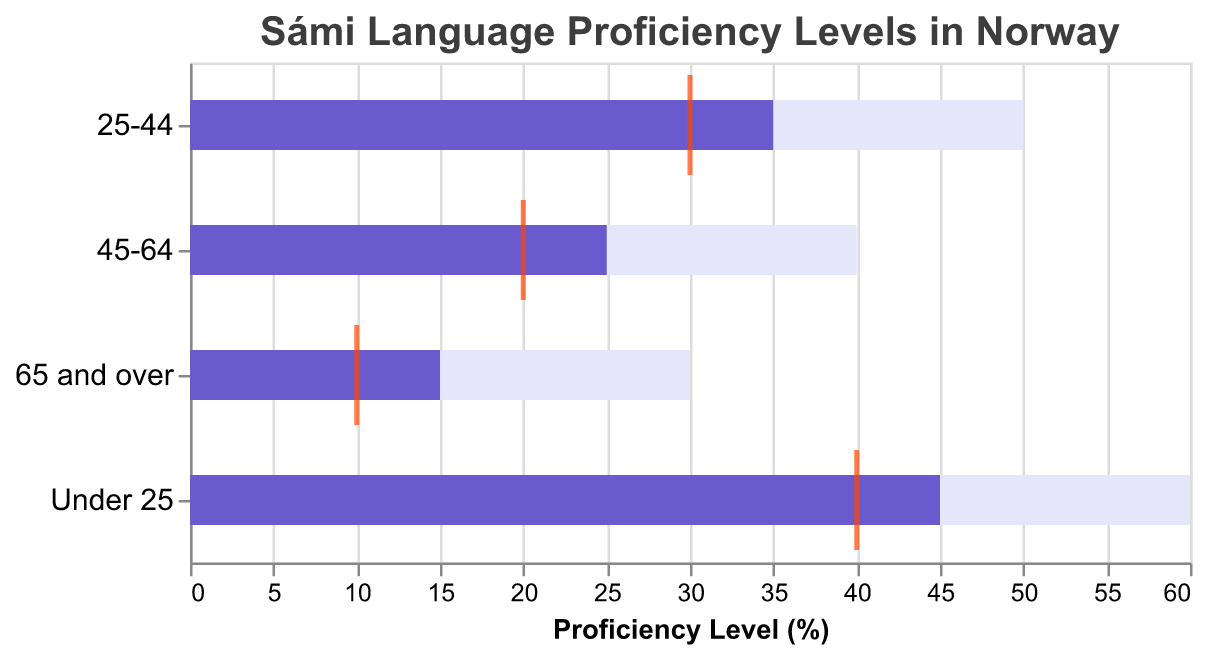How many age groups are displayed in the figure? The figure shows data for different age groups represented on the vertical axis. By counting the distinct labels, we can see there are four age groups: "Under 25", "25-44", "45-64", and "65 and over".
Answer: Four What is the proficiency level target for the "Under 25" age group? The target proficiency level for each age group is represented by the length of the light purple bars. According to the data, the target for the "Under 25" age group is 60%.
Answer: 60% Which age group has the highest average proficiency level in Sámi language? The average proficiency level for each age group is indicated by the position of the orange tick mark. By examining the figure, the "Under 25" age group has the highest average level at 40%.
Answer: Under 25 What is the difference between the target and proficient levels for the "25-44" age group? The target level for the "25-44" age group is 50%, and the proficient level is 35%. Subtracting these gives us 50 - 35 = 15.
Answer: 15 Which age group shows the smallest gap between the proficient and average proficiency levels? The proficient and average proficiency levels can be compared for each age group. The smallest gap is for the "25-44" age group, where the proficiency level is 35% and the average is 30%, resulting in a gap of 5.
Answer: 25-44 In which age group is the actual (proficient) level closest to the target level? By comparing the lengths of the light purple (target) and dark purple (proficient) bars for each age group, we observe that the smallest disparity between target and proficient levels is in the "25-44" age group (35 proficient versus 50 target, a difference of 15).
Answer: 25-44 What is the total proficiency level sum across all age groups? To find the total sum, we add the proficiency levels for all age groups: 45 (Under 25) + 35 (25-44) + 25 (45-64) + 15 (65 and over) = 120.
Answer: 120 How does the proficiency level for the "65 and over" age group compare to the target level for the same group? For the "65 and over" age group, the proficient level is 15%, and the target level is 30%. The proficient level is half of the target level.
Answer: Half What can we infer from the proficiency trend across age groups as shown in the figure? By examining the figure, it's evident that younger age groups have higher proficiency levels compared to older ones. For example, the "Under 25" group shows a proficient level of 45%, decreasing consistently with age.
Answer: Younger age groups are more proficient What's the difference between the highest and lowest average proficiency levels? The highest average proficiency level is for the "Under 25" age group (40%), and the lowest is for the "65 and over" age group (10%). The difference is 40 - 10 = 30.
Answer: 30 